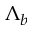<formula> <loc_0><loc_0><loc_500><loc_500>\Lambda _ { b }</formula> 